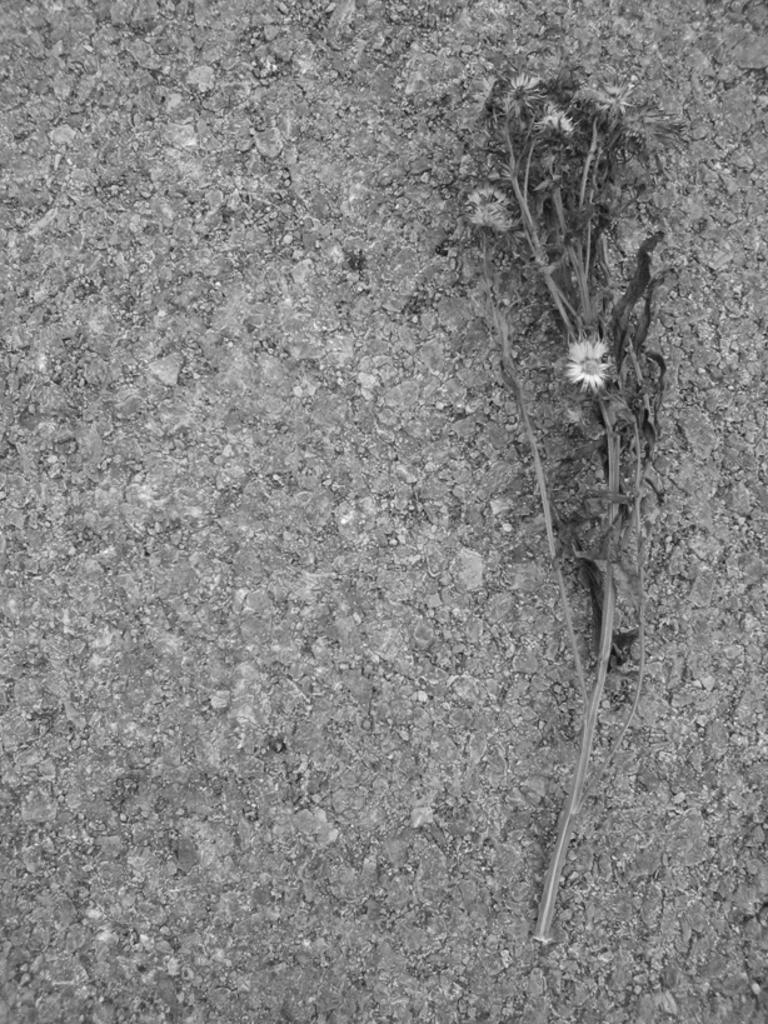What type of surface is visible in the image? There is a ground surface in the image. What can be seen on the ground surface? There is a dried plant in the image. What is the condition of the plant? The dried plant has dried flowers. What type of iron is being used to drive the bottle in the image? There is no iron or bottle present in the image. 